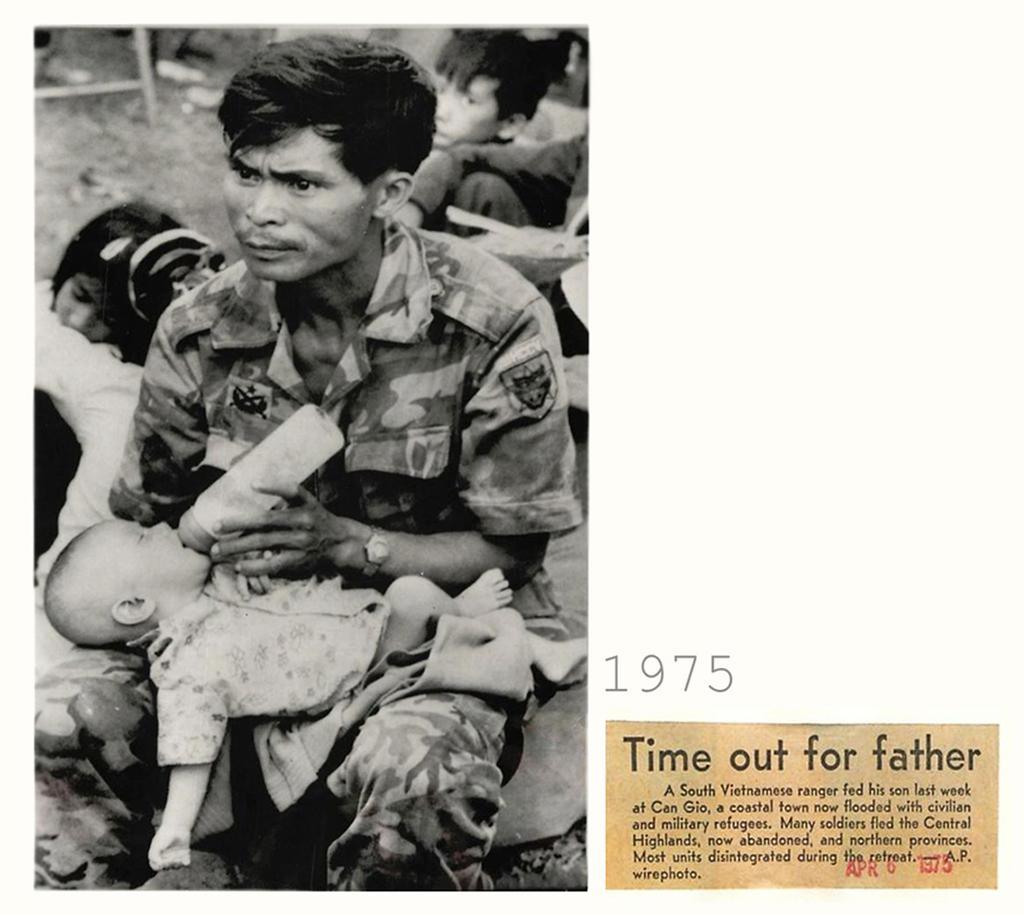Please provide a concise description of this image. In the center of the image we can see a man sitting and feeding a baby. In the background there are people. 